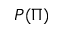<formula> <loc_0><loc_0><loc_500><loc_500>P ( \Pi )</formula> 